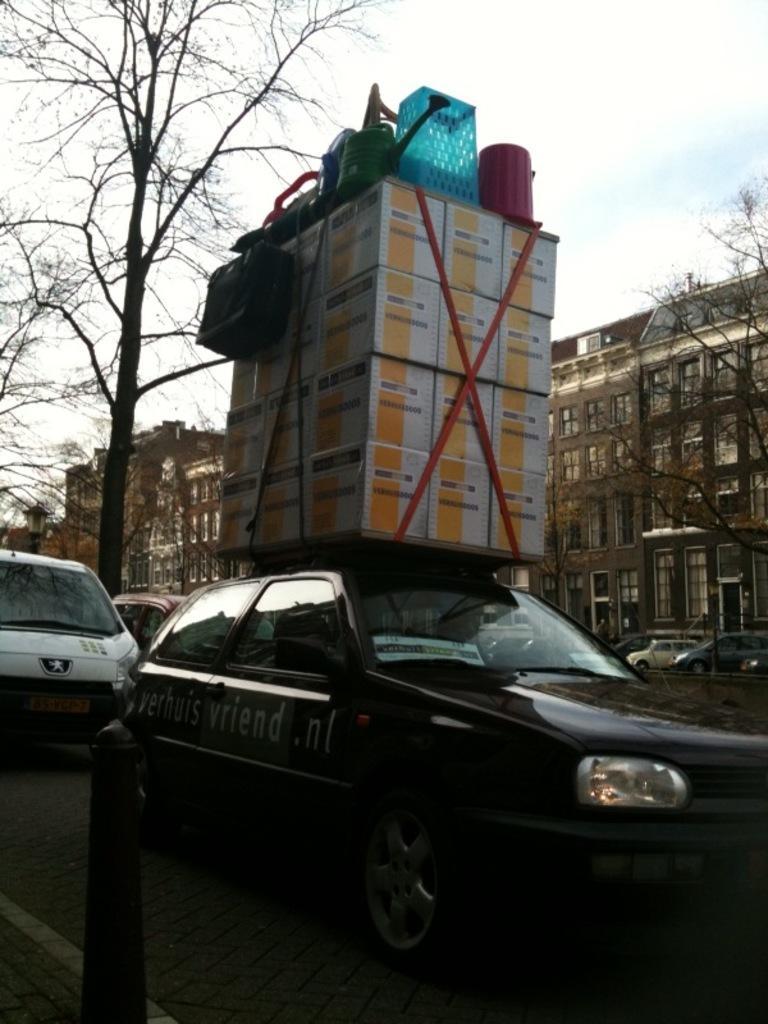Describe this image in one or two sentences. In this image we can see motor vehicles on the road and one of them is carrying luggage on its top. In the background we can see buildings, trees, barrier poles and sky with clouds. 